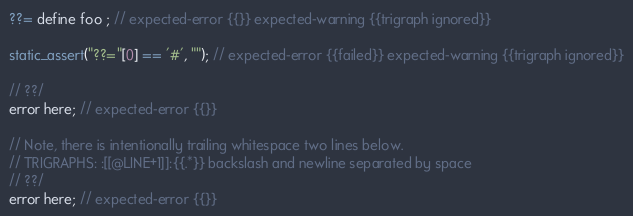Convert code to text. <code><loc_0><loc_0><loc_500><loc_500><_C++_>??= define foo ; // expected-error {{}} expected-warning {{trigraph ignored}}

static_assert("??="[0] == '#', ""); // expected-error {{failed}} expected-warning {{trigraph ignored}}

// ??/
error here; // expected-error {{}}

// Note, there is intentionally trailing whitespace two lines below.
// TRIGRAPHS: :[[@LINE+1]]:{{.*}} backslash and newline separated by space
// ??/  
error here; // expected-error {{}}
</code> 